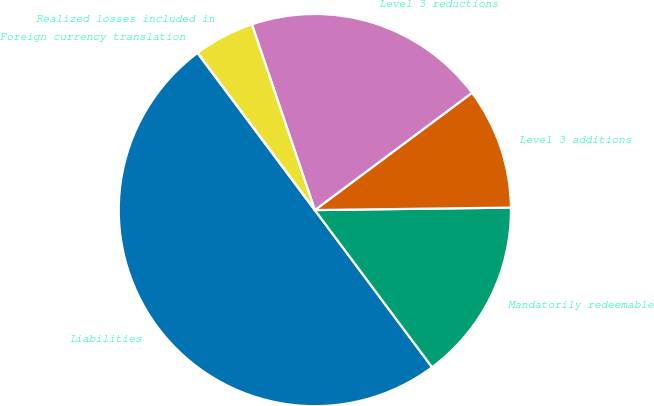Convert chart. <chart><loc_0><loc_0><loc_500><loc_500><pie_chart><fcel>Liabilities<fcel>Mandatorily redeemable<fcel>Level 3 additions<fcel>Level 3 reductions<fcel>Realized losses included in<fcel>Foreign currency translation<nl><fcel>50.0%<fcel>15.0%<fcel>10.0%<fcel>20.0%<fcel>5.0%<fcel>0.0%<nl></chart> 